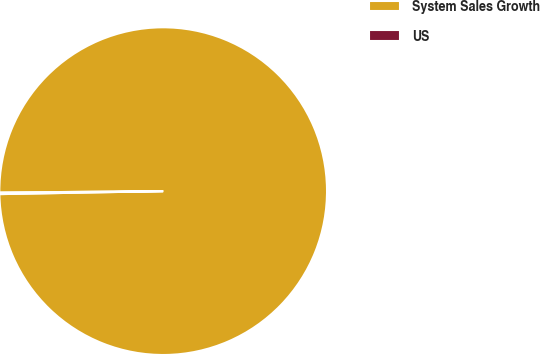<chart> <loc_0><loc_0><loc_500><loc_500><pie_chart><fcel>System Sales Growth<fcel>US<nl><fcel>99.85%<fcel>0.15%<nl></chart> 